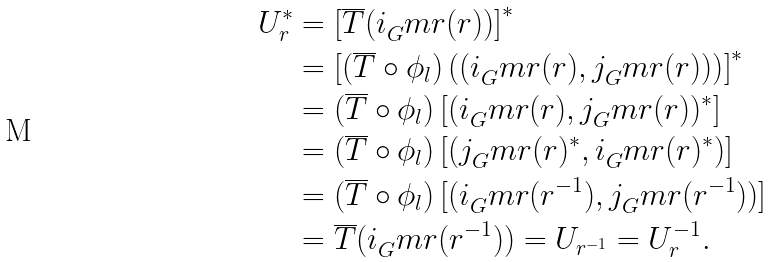<formula> <loc_0><loc_0><loc_500><loc_500>U _ { r } ^ { * } & = \left [ \overline { T } ( i _ { G } ^ { \ } m r ( r ) ) \right ] ^ { * } \\ & = \left [ \left ( \overline { T } \circ \phi _ { l } \right ) \left ( ( i _ { G } ^ { \ } m r ( r ) , j _ { G } ^ { \ } m r ( r ) ) \right ) \right ] ^ { * } \\ & = \left ( \overline { T } \circ \phi _ { l } \right ) \left [ ( i _ { G } ^ { \ } m r ( r ) , j _ { G } ^ { \ } m r ( r ) ) ^ { * } \right ] \\ & = \left ( \overline { T } \circ \phi _ { l } \right ) \left [ ( j _ { G } ^ { \ } m r ( r ) ^ { * } , i _ { G } ^ { \ } m r ( r ) ^ { * } ) \right ] \\ & = \left ( \overline { T } \circ \phi _ { l } \right ) [ ( i _ { G } ^ { \ } m r ( r ^ { - 1 } ) , j _ { G } ^ { \ } m r ( r ^ { - 1 } ) ) ] \\ & = \overline { T } ( i _ { G } ^ { \ } m r ( r ^ { - 1 } ) ) = U _ { r ^ { - 1 } } = U _ { r } ^ { - 1 } .</formula> 